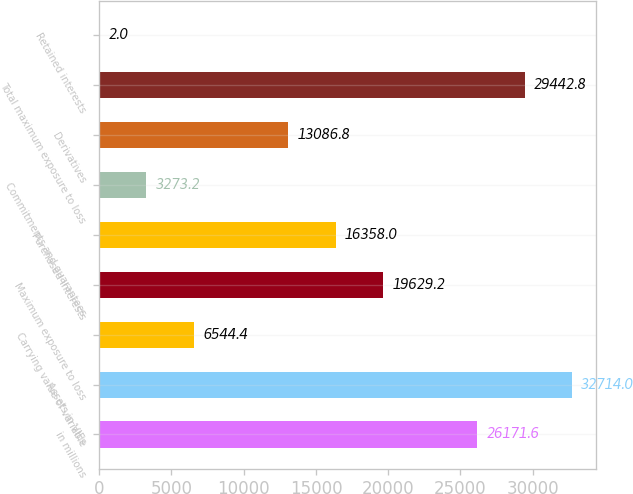Convert chart to OTSL. <chart><loc_0><loc_0><loc_500><loc_500><bar_chart><fcel>in millions<fcel>Assets in VIEs<fcel>Carrying value of variable<fcel>Maximum exposure to loss<fcel>Purchased interests<fcel>Commitments and guarantees<fcel>Derivatives<fcel>Total maximum exposure to loss<fcel>Retained interests<nl><fcel>26171.6<fcel>32714<fcel>6544.4<fcel>19629.2<fcel>16358<fcel>3273.2<fcel>13086.8<fcel>29442.8<fcel>2<nl></chart> 